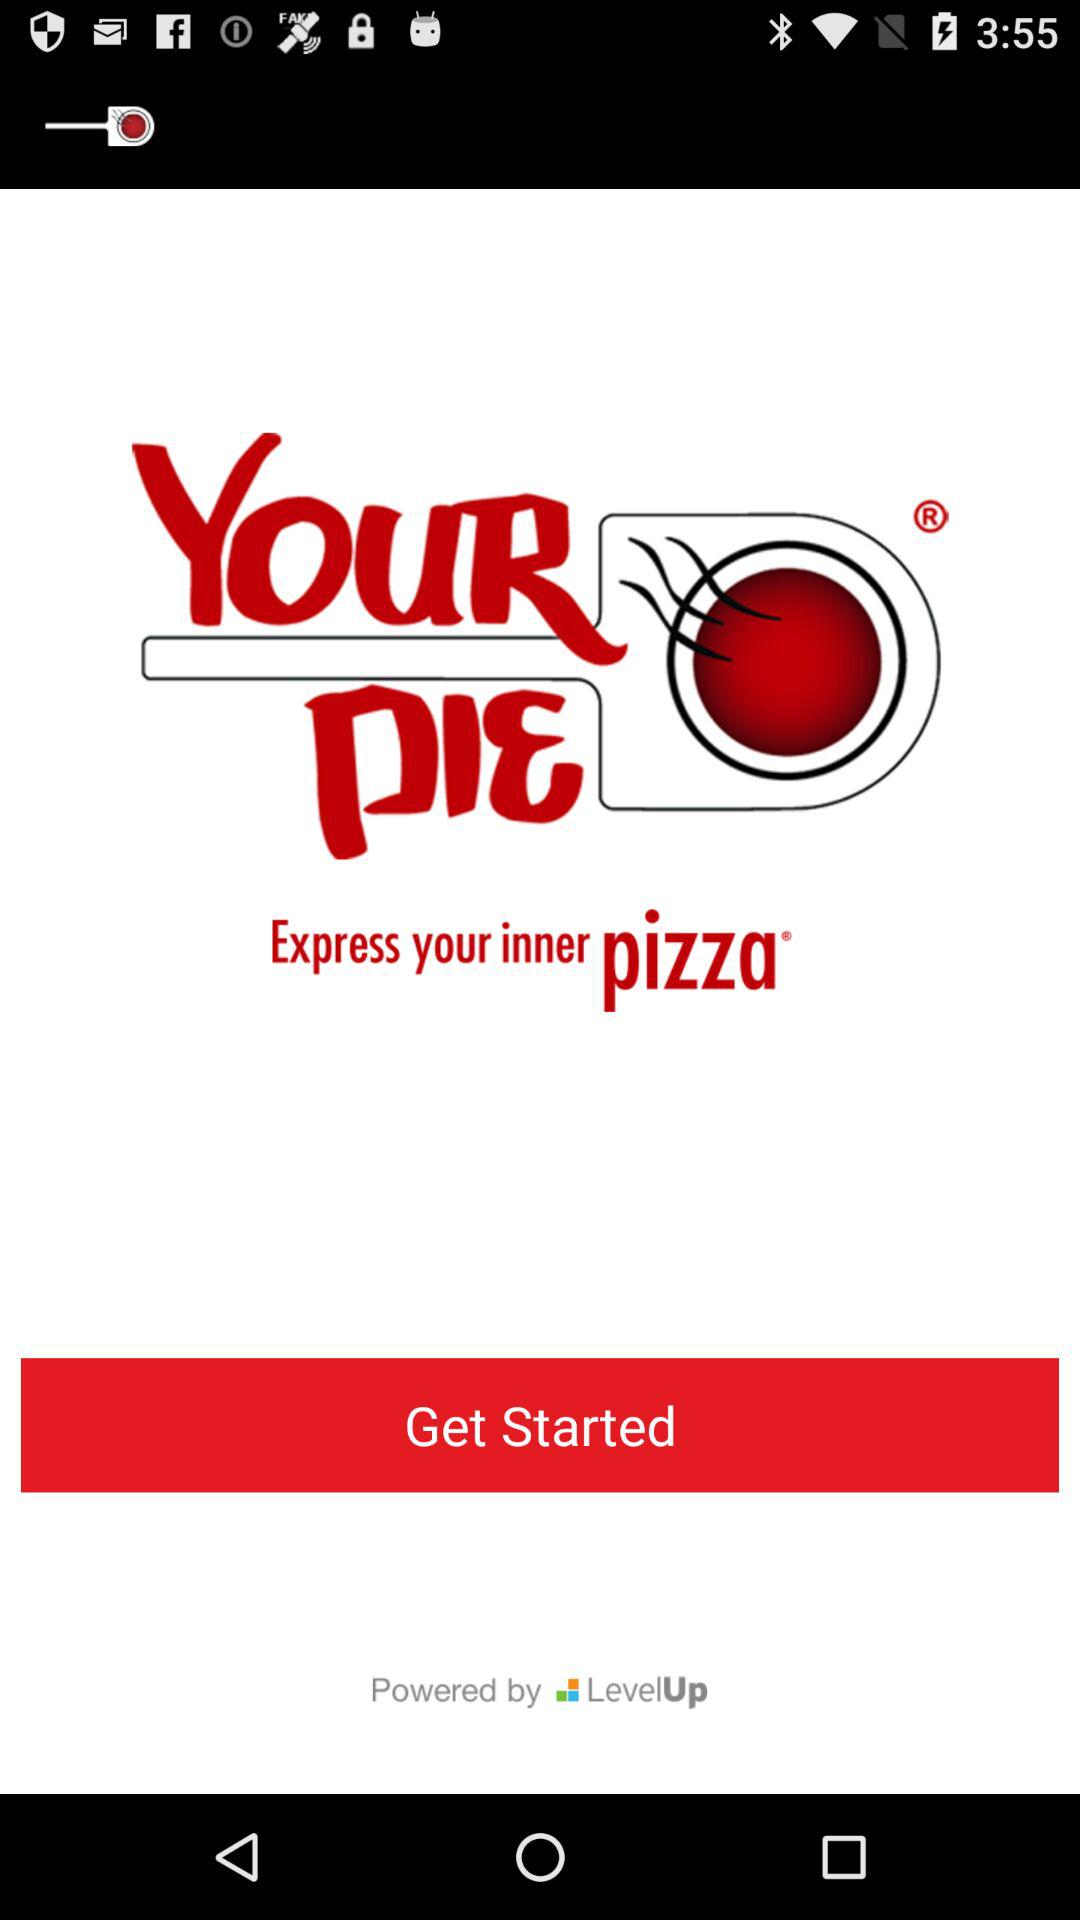What is the name of the application? The name of the application is "Your Pie Rewards". 